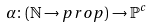Convert formula to latex. <formula><loc_0><loc_0><loc_500><loc_500>& \alpha \colon ( \mathbb { N } \rightarrow p r o p ) \rightarrow \mathbb { P } ^ { c }</formula> 